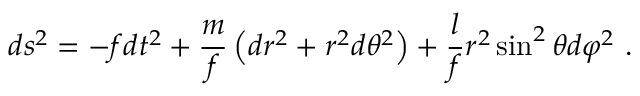Convert formula to latex. <formula><loc_0><loc_0><loc_500><loc_500>d s ^ { 2 } = - f d t ^ { 2 } + \frac { m } { f } \left ( d r ^ { 2 } + r ^ { 2 } d \theta ^ { 2 } \right ) + \frac { l } { f } r ^ { 2 } \sin ^ { 2 } \theta d \varphi ^ { 2 } \ .</formula> 